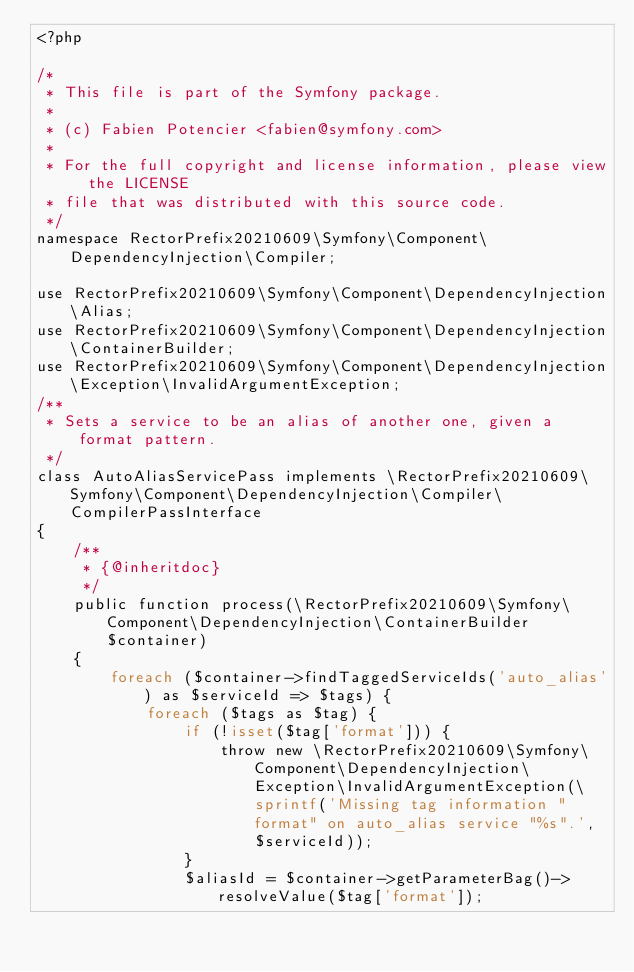<code> <loc_0><loc_0><loc_500><loc_500><_PHP_><?php

/*
 * This file is part of the Symfony package.
 *
 * (c) Fabien Potencier <fabien@symfony.com>
 *
 * For the full copyright and license information, please view the LICENSE
 * file that was distributed with this source code.
 */
namespace RectorPrefix20210609\Symfony\Component\DependencyInjection\Compiler;

use RectorPrefix20210609\Symfony\Component\DependencyInjection\Alias;
use RectorPrefix20210609\Symfony\Component\DependencyInjection\ContainerBuilder;
use RectorPrefix20210609\Symfony\Component\DependencyInjection\Exception\InvalidArgumentException;
/**
 * Sets a service to be an alias of another one, given a format pattern.
 */
class AutoAliasServicePass implements \RectorPrefix20210609\Symfony\Component\DependencyInjection\Compiler\CompilerPassInterface
{
    /**
     * {@inheritdoc}
     */
    public function process(\RectorPrefix20210609\Symfony\Component\DependencyInjection\ContainerBuilder $container)
    {
        foreach ($container->findTaggedServiceIds('auto_alias') as $serviceId => $tags) {
            foreach ($tags as $tag) {
                if (!isset($tag['format'])) {
                    throw new \RectorPrefix20210609\Symfony\Component\DependencyInjection\Exception\InvalidArgumentException(\sprintf('Missing tag information "format" on auto_alias service "%s".', $serviceId));
                }
                $aliasId = $container->getParameterBag()->resolveValue($tag['format']);</code> 